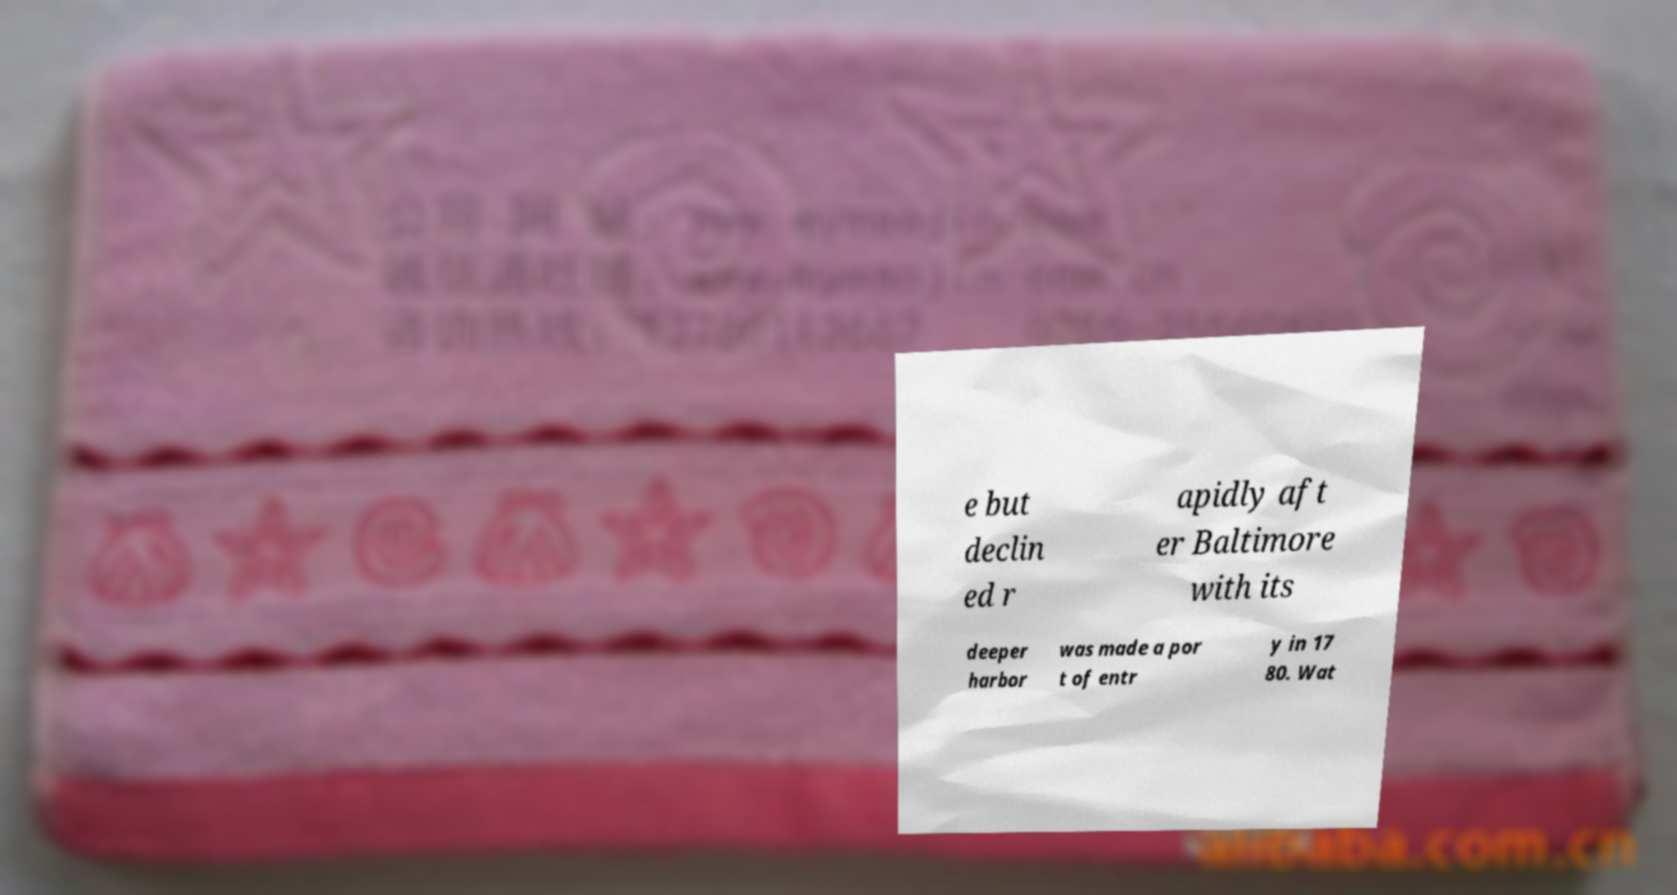I need the written content from this picture converted into text. Can you do that? e but declin ed r apidly aft er Baltimore with its deeper harbor was made a por t of entr y in 17 80. Wat 